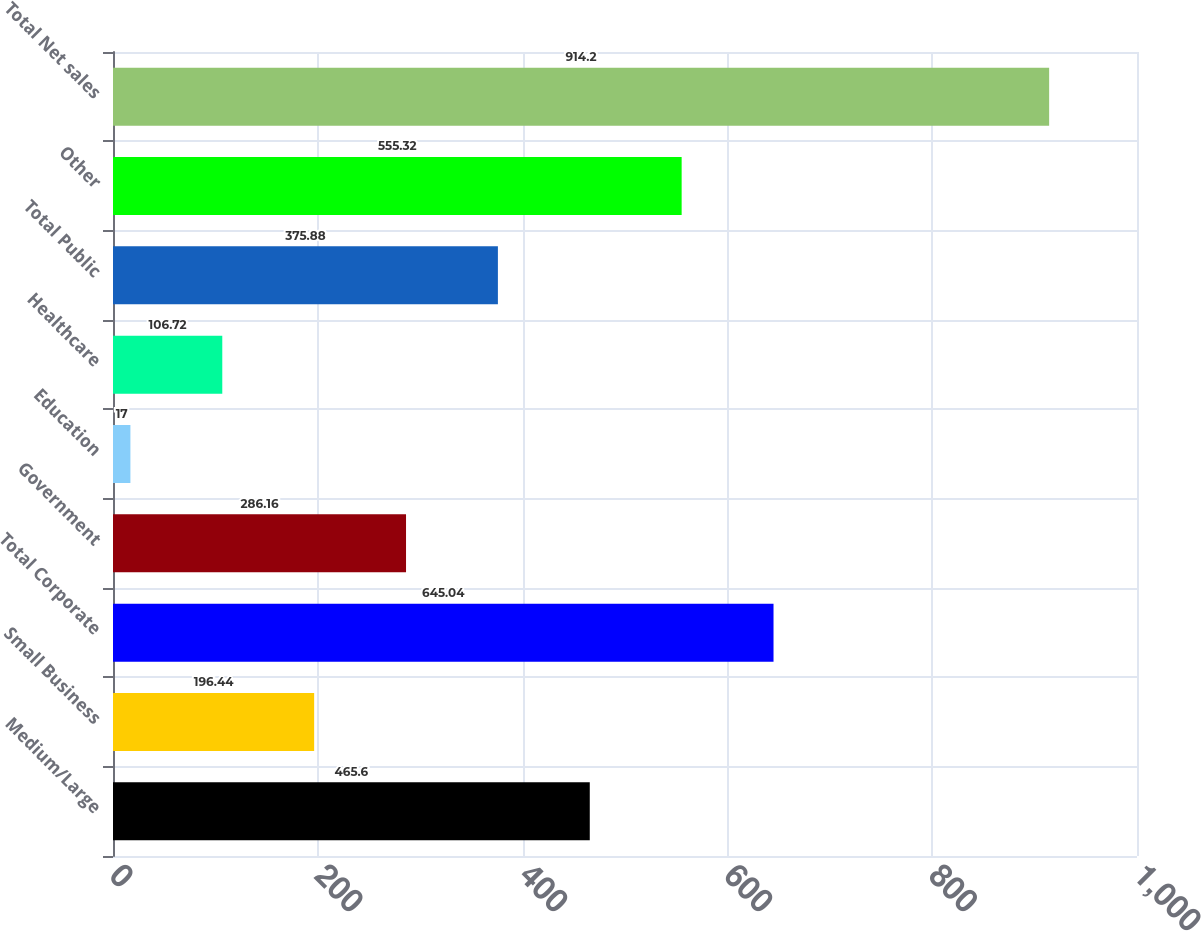Convert chart to OTSL. <chart><loc_0><loc_0><loc_500><loc_500><bar_chart><fcel>Medium/Large<fcel>Small Business<fcel>Total Corporate<fcel>Government<fcel>Education<fcel>Healthcare<fcel>Total Public<fcel>Other<fcel>Total Net sales<nl><fcel>465.6<fcel>196.44<fcel>645.04<fcel>286.16<fcel>17<fcel>106.72<fcel>375.88<fcel>555.32<fcel>914.2<nl></chart> 